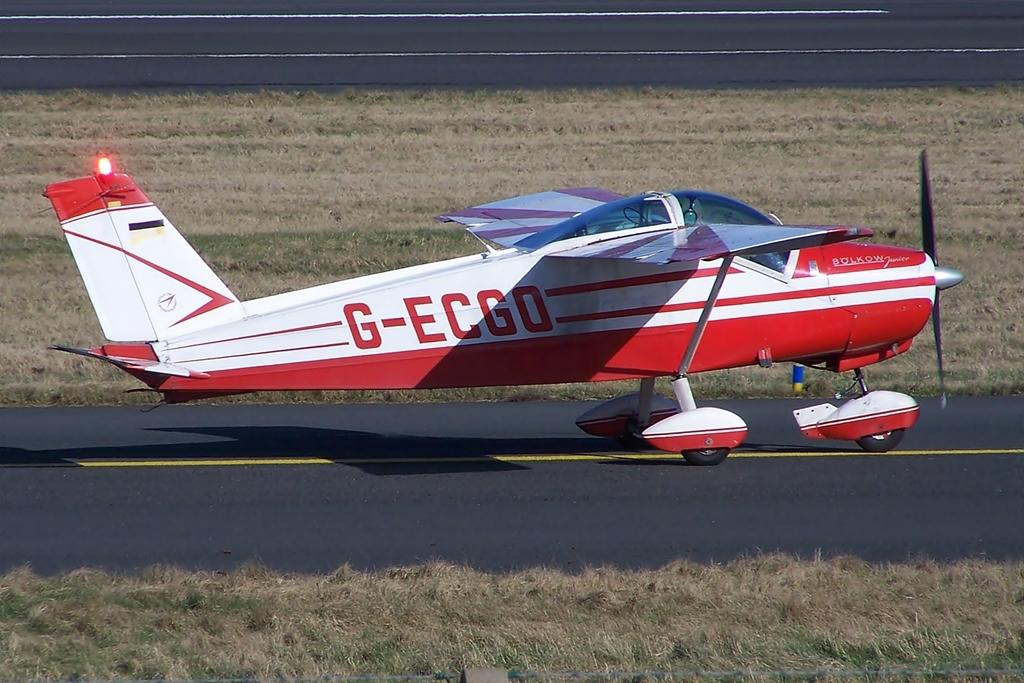<image>
Summarize the visual content of the image. a private plane with the letters G-ECGO is sitting on the tarmack 